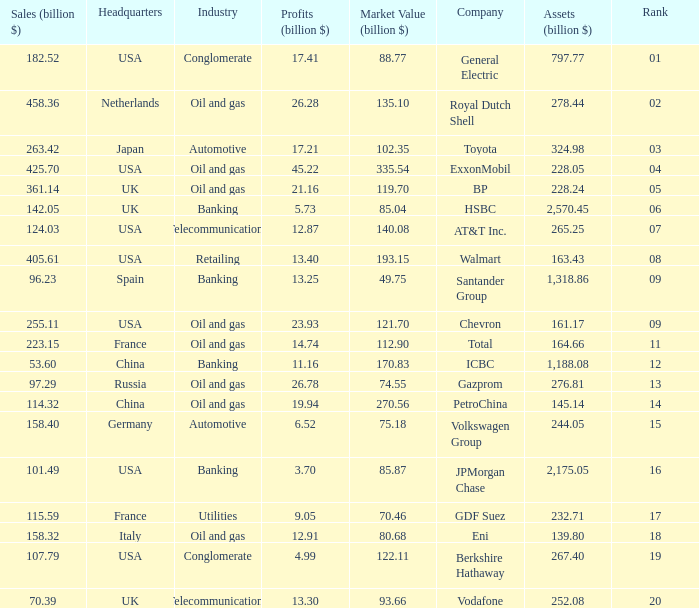Would you be able to parse every entry in this table? {'header': ['Sales (billion $)', 'Headquarters', 'Industry', 'Profits (billion $)', 'Market Value (billion $)', 'Company', 'Assets (billion $)', 'Rank'], 'rows': [['182.52', 'USA', 'Conglomerate', '17.41', '88.77', 'General Electric', '797.77', '01'], ['458.36', 'Netherlands', 'Oil and gas', '26.28', '135.10', 'Royal Dutch Shell', '278.44', '02'], ['263.42', 'Japan', 'Automotive', '17.21', '102.35', 'Toyota', '324.98', '03'], ['425.70', 'USA', 'Oil and gas', '45.22', '335.54', 'ExxonMobil', '228.05', '04'], ['361.14', 'UK', 'Oil and gas', '21.16', '119.70', 'BP', '228.24', '05'], ['142.05', 'UK', 'Banking', '5.73', '85.04', 'HSBC', '2,570.45', '06'], ['124.03', 'USA', 'Telecommunications', '12.87', '140.08', 'AT&T Inc.', '265.25', '07'], ['405.61', 'USA', 'Retailing', '13.40', '193.15', 'Walmart', '163.43', '08'], ['96.23', 'Spain', 'Banking', '13.25', '49.75', 'Santander Group', '1,318.86', '09'], ['255.11', 'USA', 'Oil and gas', '23.93', '121.70', 'Chevron', '161.17', '09'], ['223.15', 'France', 'Oil and gas', '14.74', '112.90', 'Total', '164.66', '11'], ['53.60', 'China', 'Banking', '11.16', '170.83', 'ICBC', '1,188.08', '12'], ['97.29', 'Russia', 'Oil and gas', '26.78', '74.55', 'Gazprom', '276.81', '13'], ['114.32', 'China', 'Oil and gas', '19.94', '270.56', 'PetroChina', '145.14', '14'], ['158.40', 'Germany', 'Automotive', '6.52', '75.18', 'Volkswagen Group', '244.05', '15'], ['101.49', 'USA', 'Banking', '3.70', '85.87', 'JPMorgan Chase', '2,175.05', '16'], ['115.59', 'France', 'Utilities', '9.05', '70.46', 'GDF Suez', '232.71', '17'], ['158.32', 'Italy', 'Oil and gas', '12.91', '80.68', 'Eni', '139.80', '18'], ['107.79', 'USA', 'Conglomerate', '4.99', '122.11', 'Berkshire Hathaway', '267.40', '19'], ['70.39', 'UK', 'Telecommunications', '13.30', '93.66', 'Vodafone', '252.08', '20']]} How many Assets (billion $) has an Industry of oil and gas, and a Rank of 9, and a Market Value (billion $) larger than 121.7? None. 